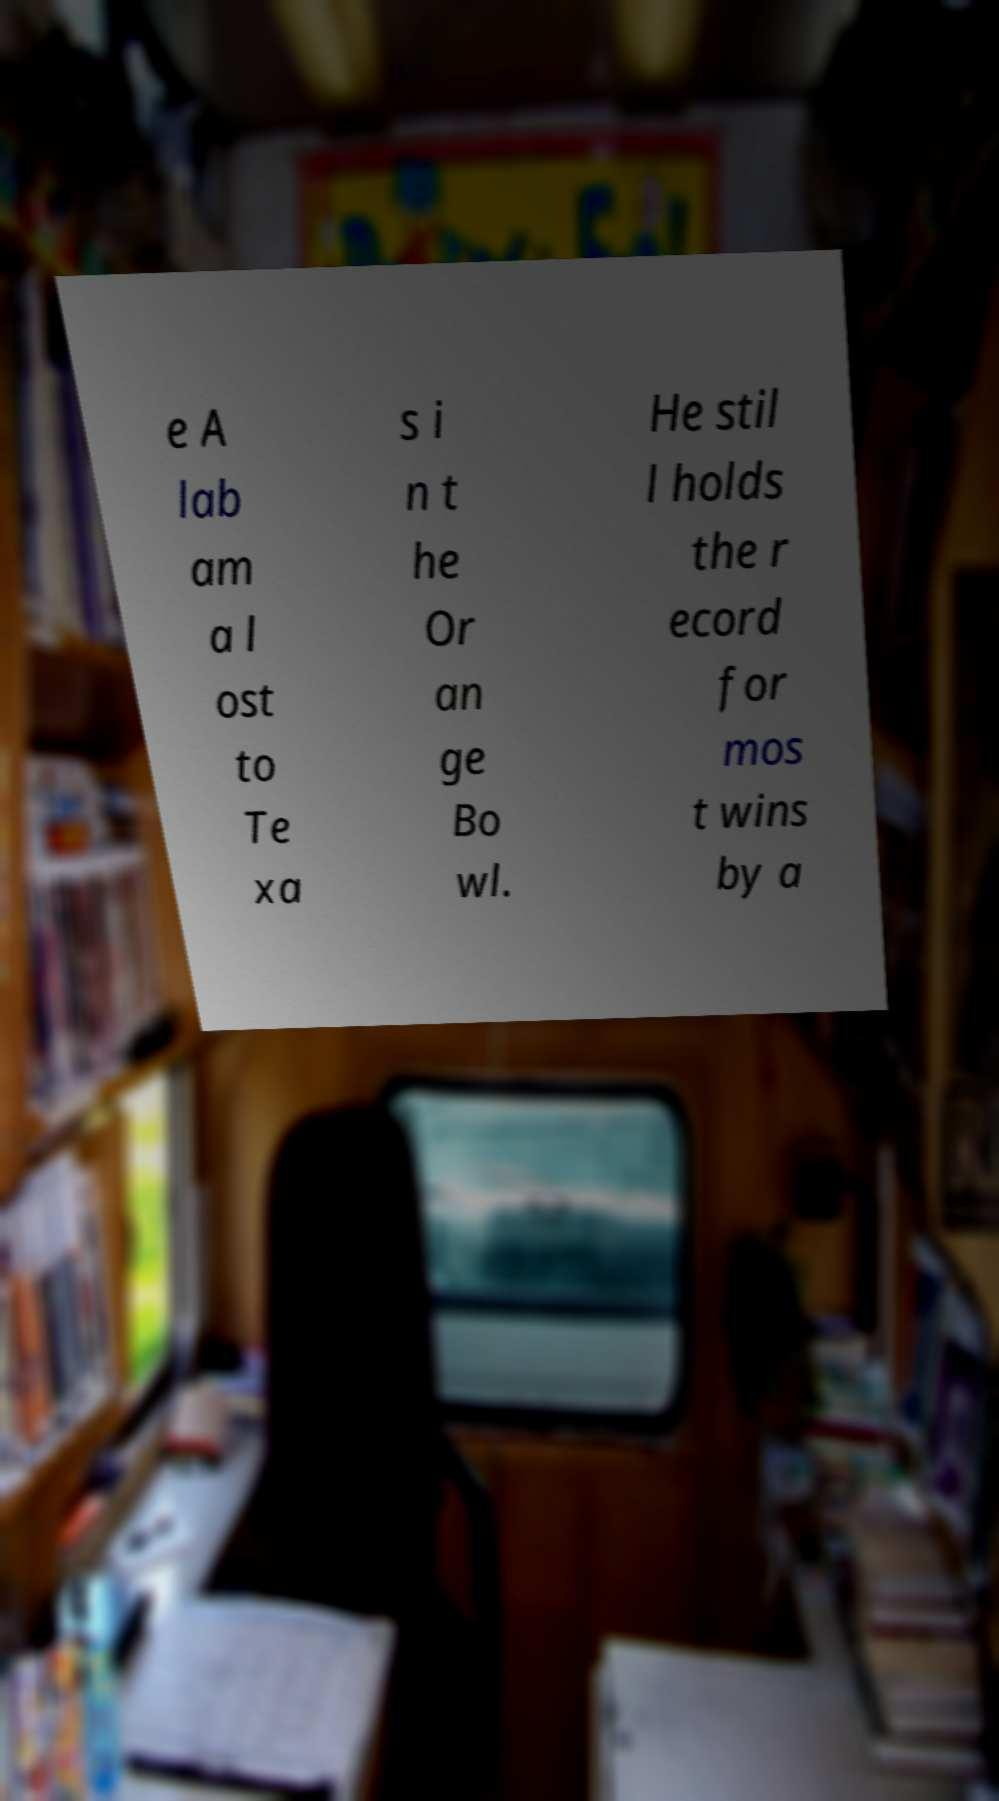What messages or text are displayed in this image? I need them in a readable, typed format. e A lab am a l ost to Te xa s i n t he Or an ge Bo wl. He stil l holds the r ecord for mos t wins by a 